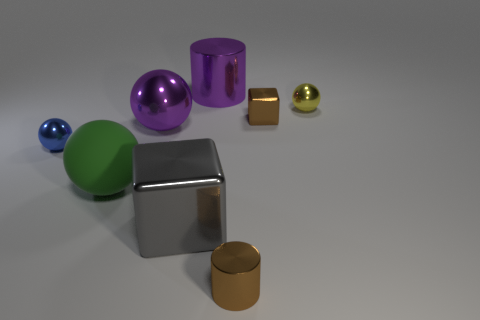Subtract all brown spheres. Subtract all yellow cylinders. How many spheres are left? 4 Add 2 tiny shiny things. How many objects exist? 10 Subtract all cylinders. How many objects are left? 6 Subtract all purple objects. Subtract all brown metallic blocks. How many objects are left? 5 Add 2 brown metal cylinders. How many brown metal cylinders are left? 3 Add 6 small metal balls. How many small metal balls exist? 8 Subtract 0 blue cylinders. How many objects are left? 8 